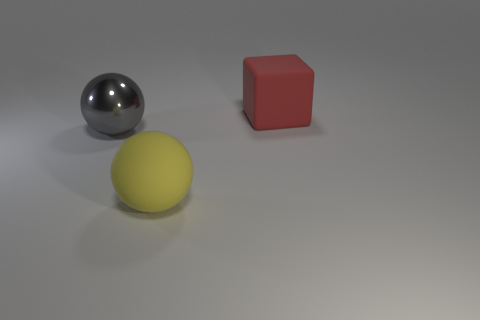What is the material of the other yellow object that is the same shape as the metal object?
Offer a terse response. Rubber. Is the number of red rubber blocks to the left of the big red object less than the number of metallic things?
Offer a terse response. Yes. Do the object that is behind the big metallic thing and the large metallic thing have the same shape?
Offer a terse response. No. There is a sphere that is made of the same material as the block; what size is it?
Your response must be concise. Large. What material is the big thing that is right of the large rubber thing that is in front of the rubber thing behind the gray metallic sphere made of?
Offer a very short reply. Rubber. Is the number of large yellow rubber spheres less than the number of large spheres?
Give a very brief answer. Yes. Is the big yellow object made of the same material as the red object?
Provide a succinct answer. Yes. There is a sphere that is in front of the gray object; is it the same color as the big shiny thing?
Ensure brevity in your answer.  No. What number of matte balls are in front of the big object in front of the big metallic ball?
Offer a terse response. 0. What is the color of the metallic ball that is the same size as the yellow thing?
Your response must be concise. Gray. 